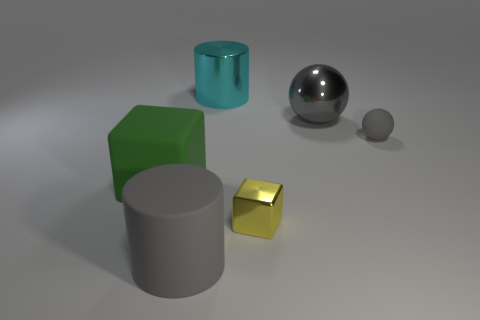Add 3 red balls. How many objects exist? 9 Subtract all blocks. How many objects are left? 4 Subtract 2 gray balls. How many objects are left? 4 Subtract all blue cubes. Subtract all yellow cubes. How many objects are left? 5 Add 1 gray matte cylinders. How many gray matte cylinders are left? 2 Add 2 large cubes. How many large cubes exist? 3 